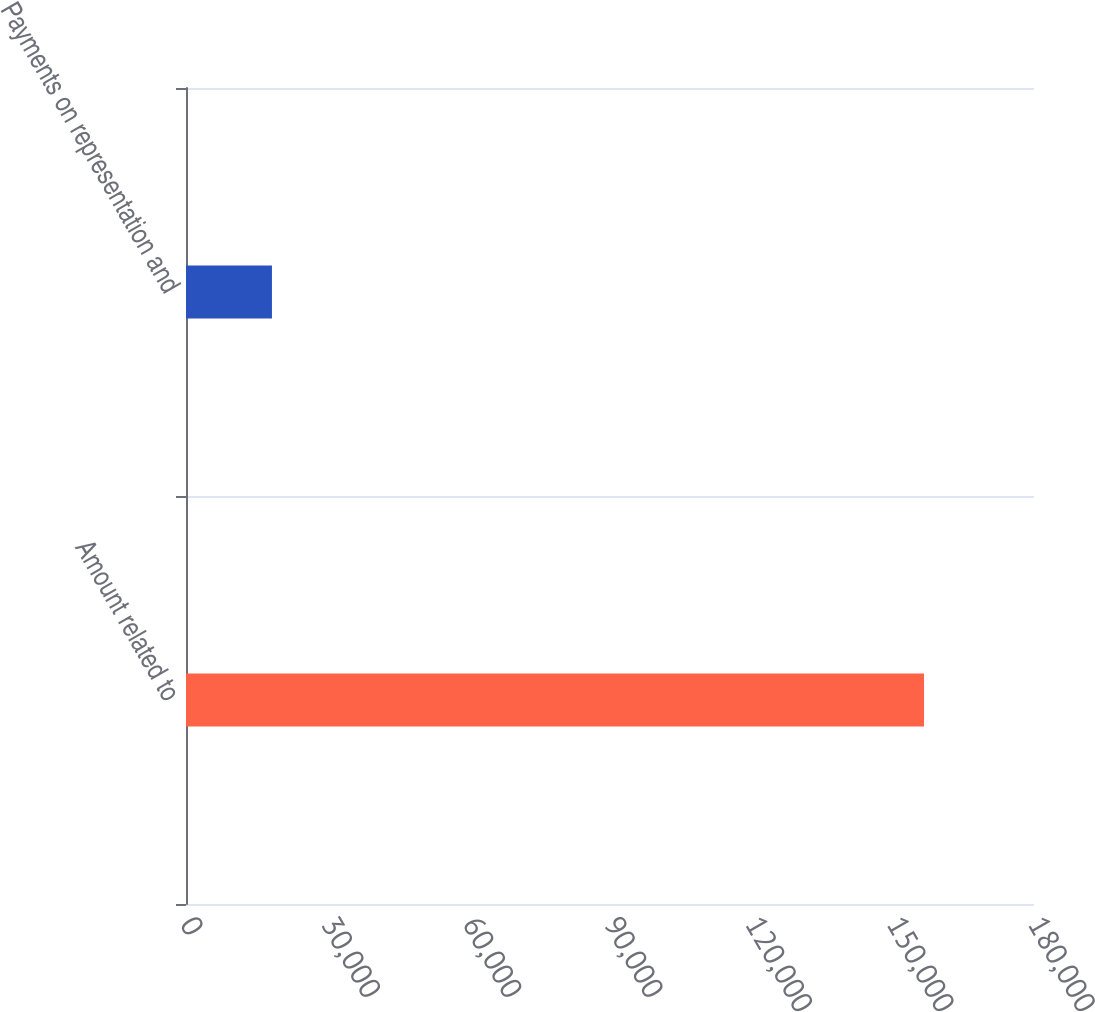Convert chart to OTSL. <chart><loc_0><loc_0><loc_500><loc_500><bar_chart><fcel>Amount related to<fcel>Payments on representation and<nl><fcel>156659<fcel>18244<nl></chart> 